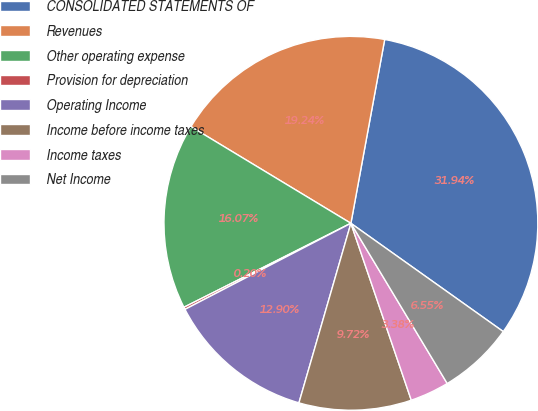Convert chart to OTSL. <chart><loc_0><loc_0><loc_500><loc_500><pie_chart><fcel>CONSOLIDATED STATEMENTS OF<fcel>Revenues<fcel>Other operating expense<fcel>Provision for depreciation<fcel>Operating Income<fcel>Income before income taxes<fcel>Income taxes<fcel>Net Income<nl><fcel>31.94%<fcel>19.24%<fcel>16.07%<fcel>0.2%<fcel>12.9%<fcel>9.72%<fcel>3.38%<fcel>6.55%<nl></chart> 